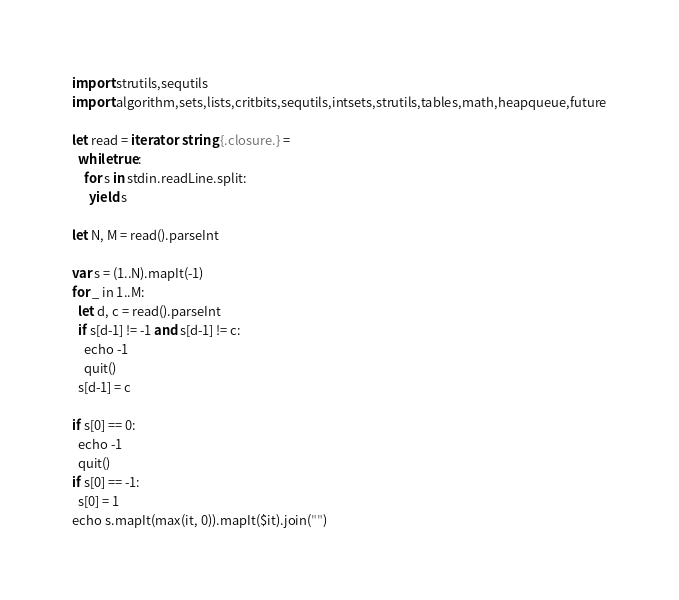<code> <loc_0><loc_0><loc_500><loc_500><_Nim_>import strutils,sequtils
import algorithm,sets,lists,critbits,sequtils,intsets,strutils,tables,math,heapqueue,future

let read = iterator: string {.closure.} =
  while true:
    for s in stdin.readLine.split:
      yield s

let N, M = read().parseInt

var s = (1..N).mapIt(-1)
for _ in 1..M:
  let d, c = read().parseInt
  if s[d-1] != -1 and s[d-1] != c:
    echo -1
    quit()
  s[d-1] = c

if s[0] == 0:
  echo -1
  quit()
if s[0] == -1:
  s[0] = 1
echo s.mapIt(max(it, 0)).mapIt($it).join("")
</code> 